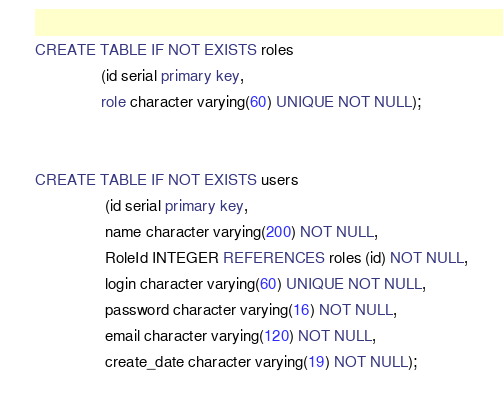Convert code to text. <code><loc_0><loc_0><loc_500><loc_500><_SQL_>CREATE TABLE IF NOT EXISTS roles
               (id serial primary key,
               role character varying(60) UNIQUE NOT NULL);


CREATE TABLE IF NOT EXISTS users
                (id serial primary key,
                name character varying(200) NOT NULL,
                RoleId INTEGER REFERENCES roles (id) NOT NULL,
                login character varying(60) UNIQUE NOT NULL,
                password character varying(16) NOT NULL,
                email character varying(120) NOT NULL,
                create_date character varying(19) NOT NULL);

</code> 